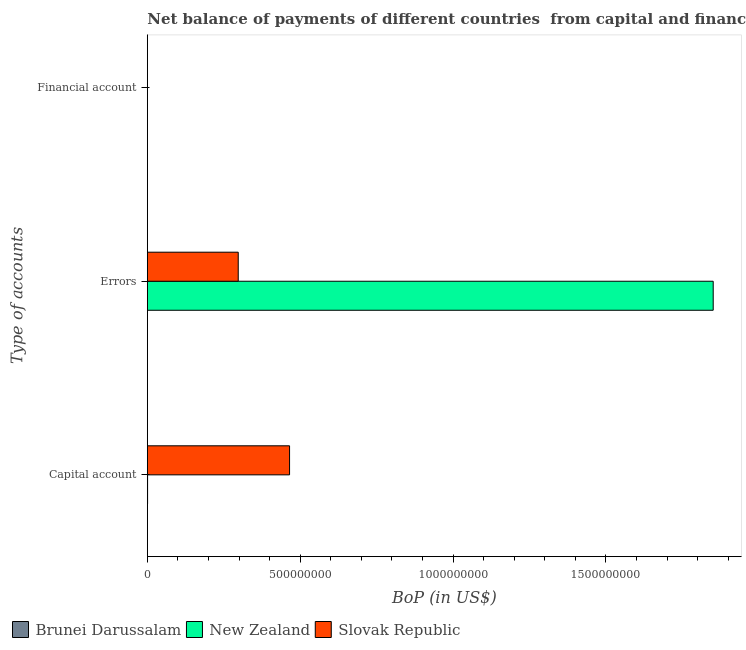How many different coloured bars are there?
Make the answer very short. 2. Are the number of bars per tick equal to the number of legend labels?
Provide a short and direct response. No. Are the number of bars on each tick of the Y-axis equal?
Give a very brief answer. No. How many bars are there on the 3rd tick from the bottom?
Ensure brevity in your answer.  0. What is the label of the 1st group of bars from the top?
Provide a short and direct response. Financial account. What is the amount of errors in New Zealand?
Keep it short and to the point. 1.85e+09. Across all countries, what is the maximum amount of errors?
Your response must be concise. 1.85e+09. In which country was the amount of net capital account maximum?
Ensure brevity in your answer.  Slovak Republic. What is the total amount of financial account in the graph?
Provide a short and direct response. 0. What is the difference between the amount of net capital account in New Zealand and that in Slovak Republic?
Your answer should be very brief. -4.64e+08. What is the difference between the amount of errors in Brunei Darussalam and the amount of net capital account in New Zealand?
Your answer should be compact. -7.64e+05. What is the average amount of net capital account per country?
Ensure brevity in your answer.  1.55e+08. What is the difference between the amount of net capital account and amount of errors in New Zealand?
Provide a short and direct response. -1.85e+09. What is the difference between the highest and the lowest amount of net capital account?
Provide a short and direct response. 4.65e+08. Is the sum of the amount of net capital account in Slovak Republic and New Zealand greater than the maximum amount of errors across all countries?
Your answer should be compact. No. Is it the case that in every country, the sum of the amount of net capital account and amount of errors is greater than the amount of financial account?
Your response must be concise. No. How many countries are there in the graph?
Your response must be concise. 3. What is the difference between two consecutive major ticks on the X-axis?
Give a very brief answer. 5.00e+08. Are the values on the major ticks of X-axis written in scientific E-notation?
Provide a short and direct response. No. Does the graph contain grids?
Ensure brevity in your answer.  No. Where does the legend appear in the graph?
Offer a very short reply. Bottom left. How are the legend labels stacked?
Your response must be concise. Horizontal. What is the title of the graph?
Your response must be concise. Net balance of payments of different countries  from capital and financial account. What is the label or title of the X-axis?
Your answer should be compact. BoP (in US$). What is the label or title of the Y-axis?
Your answer should be compact. Type of accounts. What is the BoP (in US$) in Brunei Darussalam in Capital account?
Keep it short and to the point. 0. What is the BoP (in US$) in New Zealand in Capital account?
Your answer should be very brief. 7.64e+05. What is the BoP (in US$) of Slovak Republic in Capital account?
Your answer should be very brief. 4.65e+08. What is the BoP (in US$) of New Zealand in Errors?
Offer a terse response. 1.85e+09. What is the BoP (in US$) in Slovak Republic in Errors?
Give a very brief answer. 2.97e+08. Across all Type of accounts, what is the maximum BoP (in US$) in New Zealand?
Offer a terse response. 1.85e+09. Across all Type of accounts, what is the maximum BoP (in US$) of Slovak Republic?
Keep it short and to the point. 4.65e+08. What is the total BoP (in US$) of New Zealand in the graph?
Your answer should be very brief. 1.85e+09. What is the total BoP (in US$) of Slovak Republic in the graph?
Offer a very short reply. 7.63e+08. What is the difference between the BoP (in US$) of New Zealand in Capital account and that in Errors?
Provide a succinct answer. -1.85e+09. What is the difference between the BoP (in US$) of Slovak Republic in Capital account and that in Errors?
Your response must be concise. 1.68e+08. What is the difference between the BoP (in US$) in New Zealand in Capital account and the BoP (in US$) in Slovak Republic in Errors?
Your answer should be compact. -2.97e+08. What is the average BoP (in US$) in Brunei Darussalam per Type of accounts?
Keep it short and to the point. 0. What is the average BoP (in US$) of New Zealand per Type of accounts?
Your answer should be very brief. 6.17e+08. What is the average BoP (in US$) of Slovak Republic per Type of accounts?
Your answer should be very brief. 2.54e+08. What is the difference between the BoP (in US$) in New Zealand and BoP (in US$) in Slovak Republic in Capital account?
Provide a succinct answer. -4.64e+08. What is the difference between the BoP (in US$) of New Zealand and BoP (in US$) of Slovak Republic in Errors?
Offer a very short reply. 1.55e+09. What is the ratio of the BoP (in US$) of Slovak Republic in Capital account to that in Errors?
Offer a terse response. 1.56. What is the difference between the highest and the lowest BoP (in US$) in New Zealand?
Your answer should be very brief. 1.85e+09. What is the difference between the highest and the lowest BoP (in US$) of Slovak Republic?
Your response must be concise. 4.65e+08. 